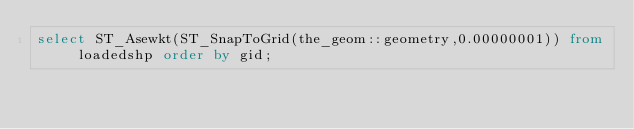Convert code to text. <code><loc_0><loc_0><loc_500><loc_500><_SQL_>select ST_Asewkt(ST_SnapToGrid(the_geom::geometry,0.00000001)) from loadedshp order by gid;

</code> 